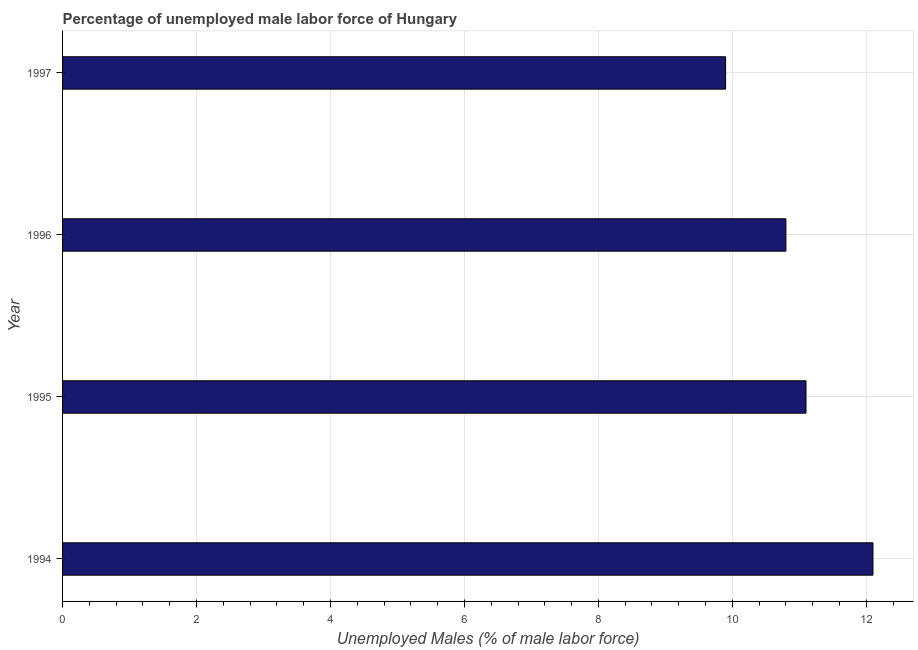Does the graph contain any zero values?
Ensure brevity in your answer.  No. Does the graph contain grids?
Offer a terse response. Yes. What is the title of the graph?
Your answer should be compact. Percentage of unemployed male labor force of Hungary. What is the label or title of the X-axis?
Ensure brevity in your answer.  Unemployed Males (% of male labor force). What is the total unemployed male labour force in 1994?
Keep it short and to the point. 12.1. Across all years, what is the maximum total unemployed male labour force?
Provide a succinct answer. 12.1. Across all years, what is the minimum total unemployed male labour force?
Provide a short and direct response. 9.9. What is the sum of the total unemployed male labour force?
Offer a terse response. 43.9. What is the difference between the total unemployed male labour force in 1995 and 1996?
Offer a terse response. 0.3. What is the average total unemployed male labour force per year?
Your answer should be very brief. 10.97. What is the median total unemployed male labour force?
Your answer should be compact. 10.95. In how many years, is the total unemployed male labour force greater than 7.6 %?
Make the answer very short. 4. What is the ratio of the total unemployed male labour force in 1994 to that in 1996?
Make the answer very short. 1.12. Is the difference between the total unemployed male labour force in 1995 and 1997 greater than the difference between any two years?
Give a very brief answer. No. Is the sum of the total unemployed male labour force in 1994 and 1997 greater than the maximum total unemployed male labour force across all years?
Provide a succinct answer. Yes. What is the difference between the highest and the lowest total unemployed male labour force?
Offer a terse response. 2.2. In how many years, is the total unemployed male labour force greater than the average total unemployed male labour force taken over all years?
Offer a very short reply. 2. Are all the bars in the graph horizontal?
Keep it short and to the point. Yes. How many years are there in the graph?
Provide a short and direct response. 4. What is the difference between two consecutive major ticks on the X-axis?
Your answer should be very brief. 2. Are the values on the major ticks of X-axis written in scientific E-notation?
Offer a very short reply. No. What is the Unemployed Males (% of male labor force) in 1994?
Offer a terse response. 12.1. What is the Unemployed Males (% of male labor force) of 1995?
Your answer should be very brief. 11.1. What is the Unemployed Males (% of male labor force) in 1996?
Offer a very short reply. 10.8. What is the Unemployed Males (% of male labor force) of 1997?
Your answer should be compact. 9.9. What is the difference between the Unemployed Males (% of male labor force) in 1994 and 1995?
Ensure brevity in your answer.  1. What is the difference between the Unemployed Males (% of male labor force) in 1995 and 1997?
Provide a short and direct response. 1.2. What is the difference between the Unemployed Males (% of male labor force) in 1996 and 1997?
Ensure brevity in your answer.  0.9. What is the ratio of the Unemployed Males (% of male labor force) in 1994 to that in 1995?
Your answer should be very brief. 1.09. What is the ratio of the Unemployed Males (% of male labor force) in 1994 to that in 1996?
Give a very brief answer. 1.12. What is the ratio of the Unemployed Males (% of male labor force) in 1994 to that in 1997?
Offer a very short reply. 1.22. What is the ratio of the Unemployed Males (% of male labor force) in 1995 to that in 1996?
Keep it short and to the point. 1.03. What is the ratio of the Unemployed Males (% of male labor force) in 1995 to that in 1997?
Give a very brief answer. 1.12. What is the ratio of the Unemployed Males (% of male labor force) in 1996 to that in 1997?
Your answer should be very brief. 1.09. 